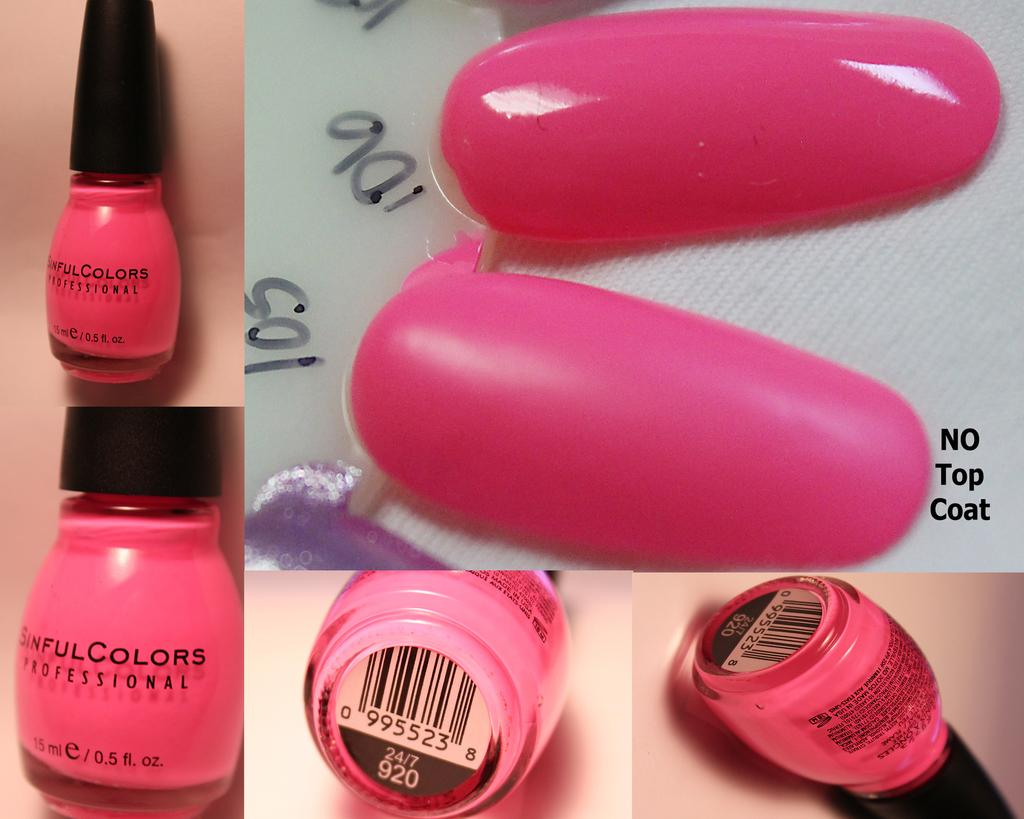<image>
Provide a brief description of the given image. A pink color Sinful Colors Professional bottle of nailpolish shown from different angles. 